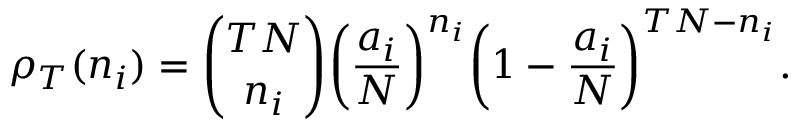Convert formula to latex. <formula><loc_0><loc_0><loc_500><loc_500>\rho _ { T } ( n _ { i } ) = { { \binom { T N } { n _ { i } } } } \left ( \frac { a _ { i } } { N } \right ) ^ { n _ { i } } \left ( 1 - \frac { a _ { i } } { N } \right ) ^ { T N - n _ { i } } .</formula> 